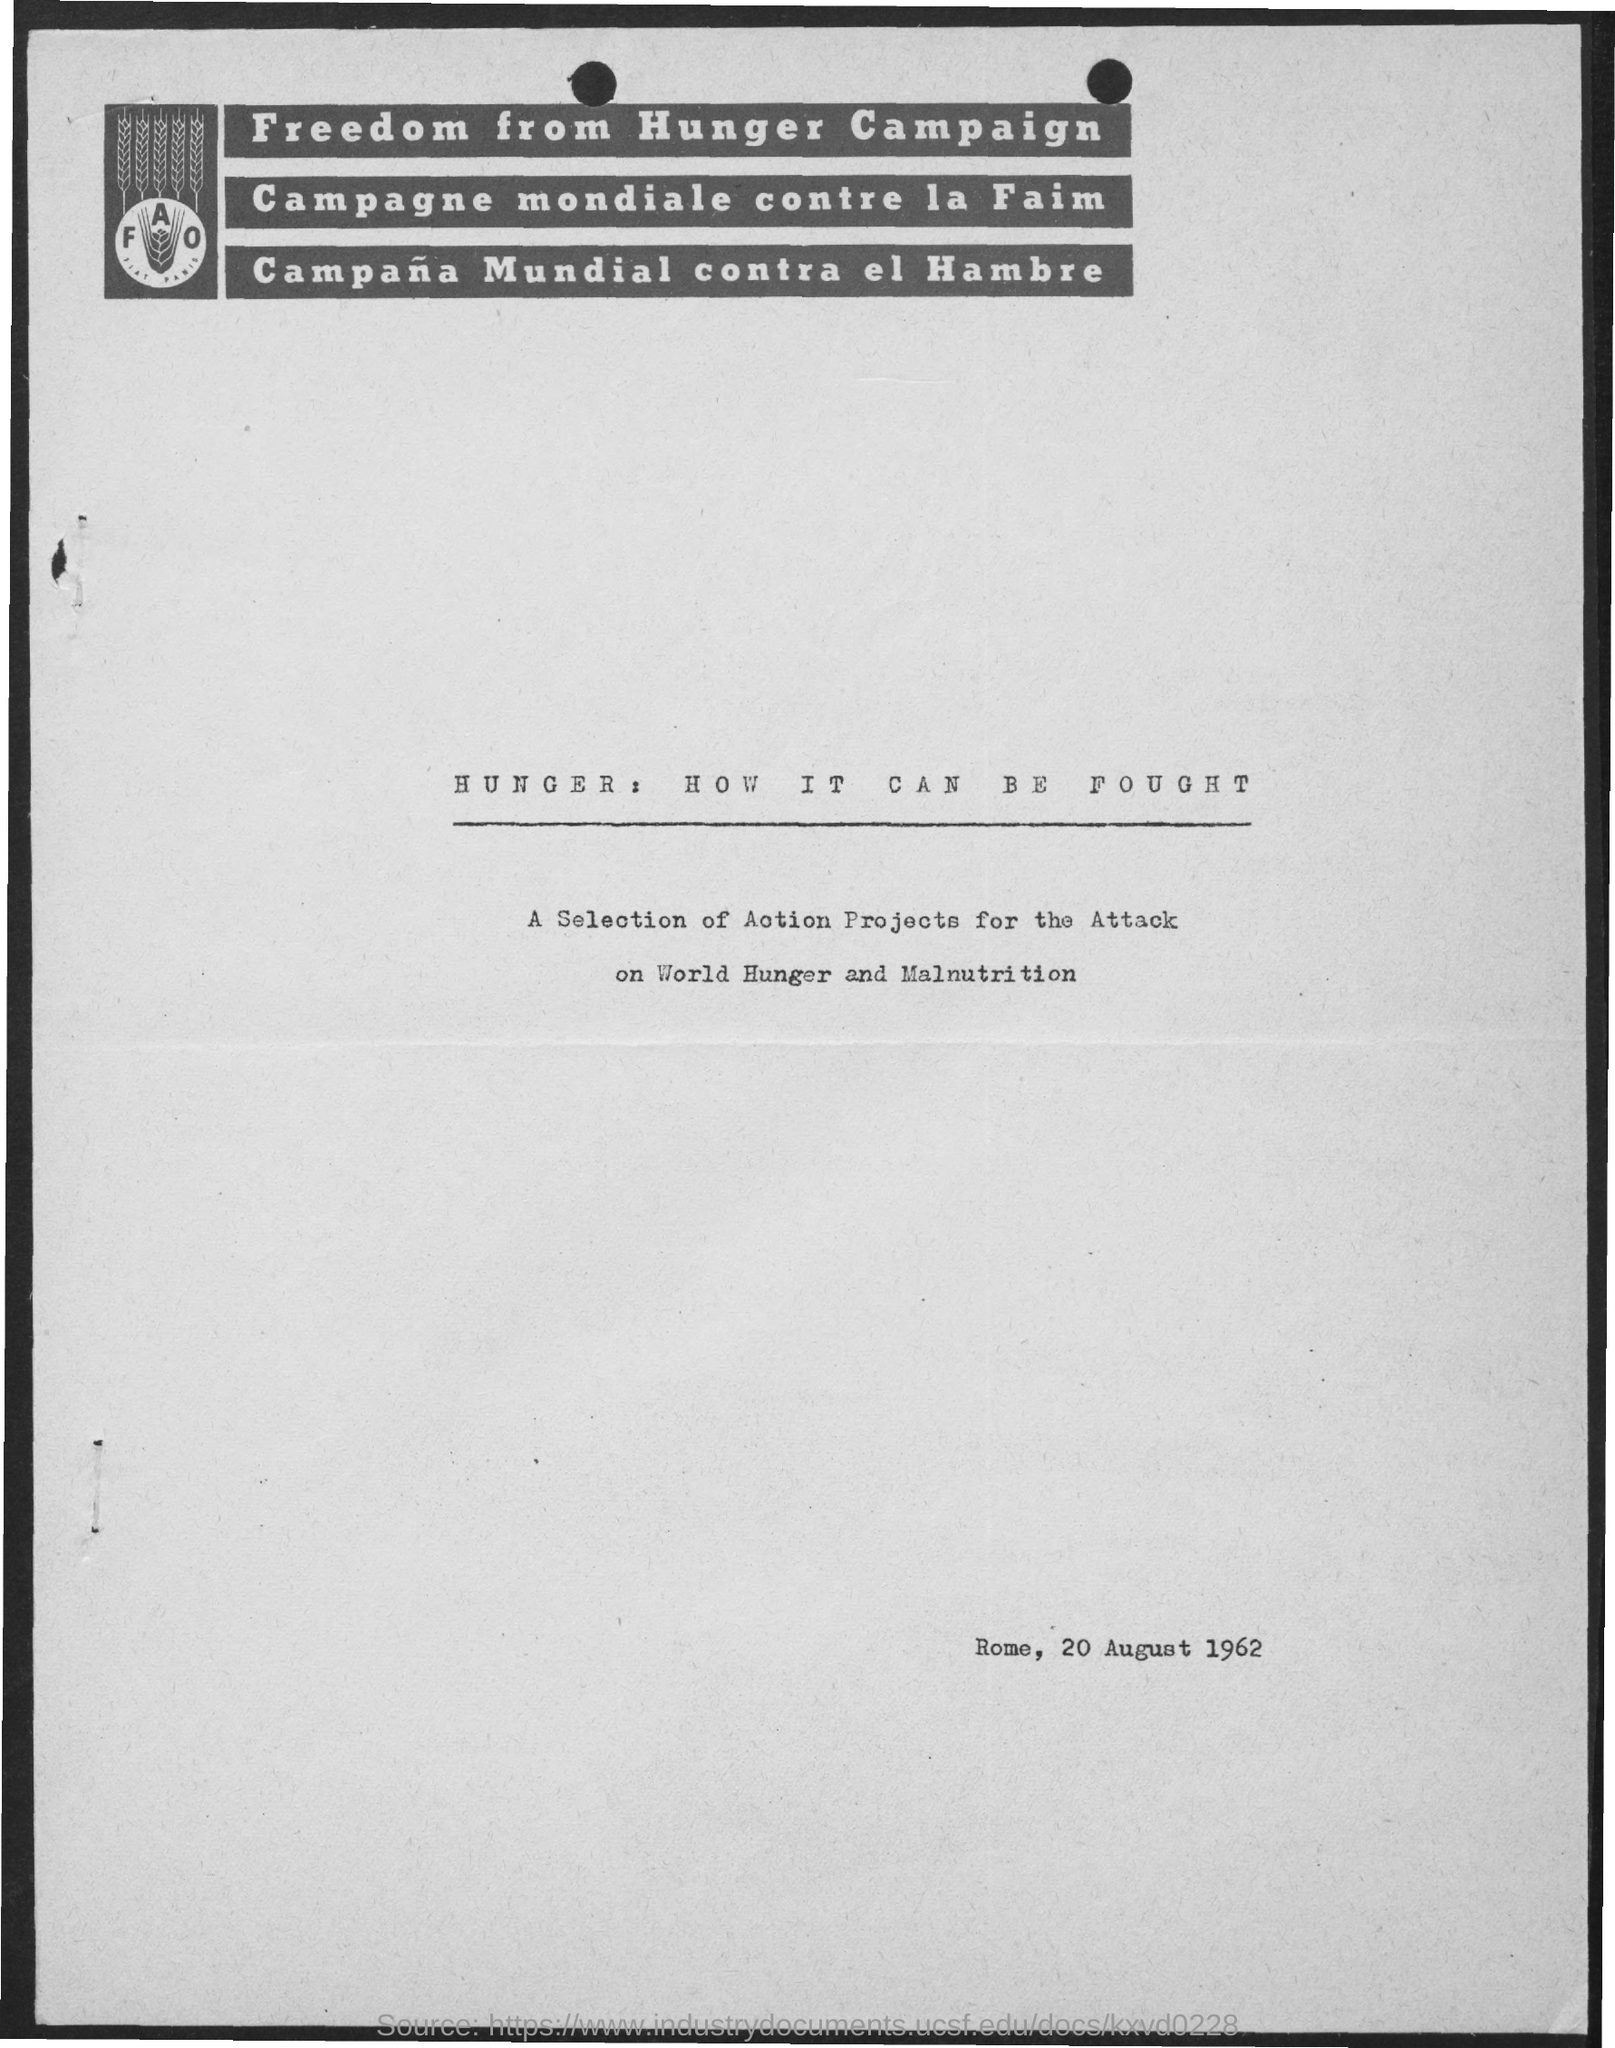Point out several critical features in this image. The document is dated August 20, 1962. The Freedom from Hunger Campaign is about achieving freedom from the burden of hunger. 